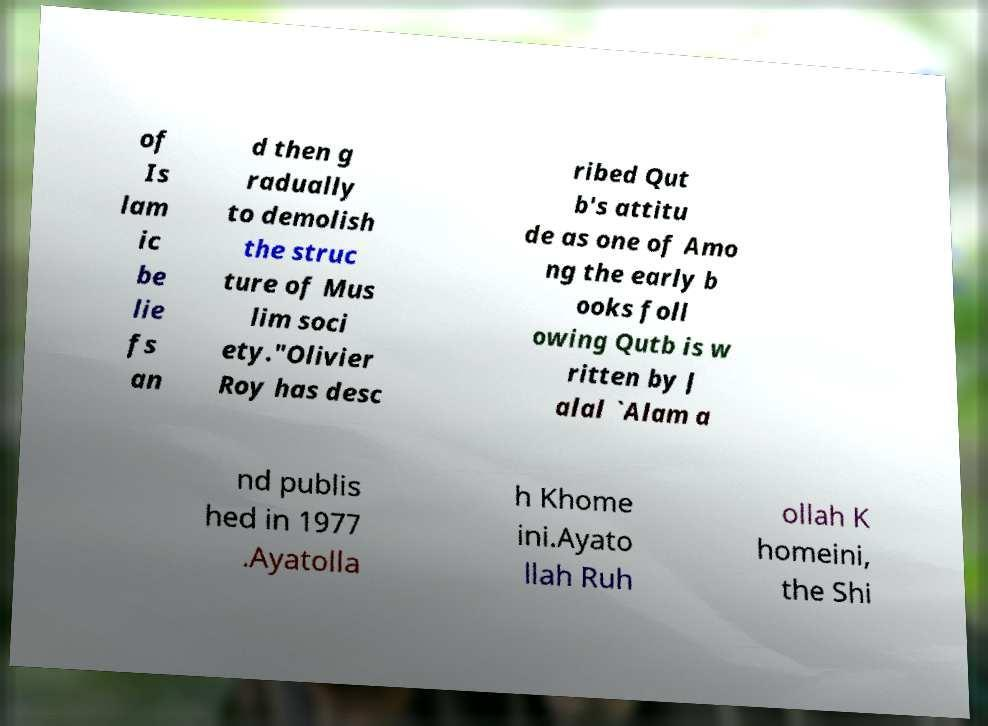Please identify and transcribe the text found in this image. of Is lam ic be lie fs an d then g radually to demolish the struc ture of Mus lim soci ety."Olivier Roy has desc ribed Qut b's attitu de as one of Amo ng the early b ooks foll owing Qutb is w ritten by J alal `Alam a nd publis hed in 1977 .Ayatolla h Khome ini.Ayato llah Ruh ollah K homeini, the Shi 